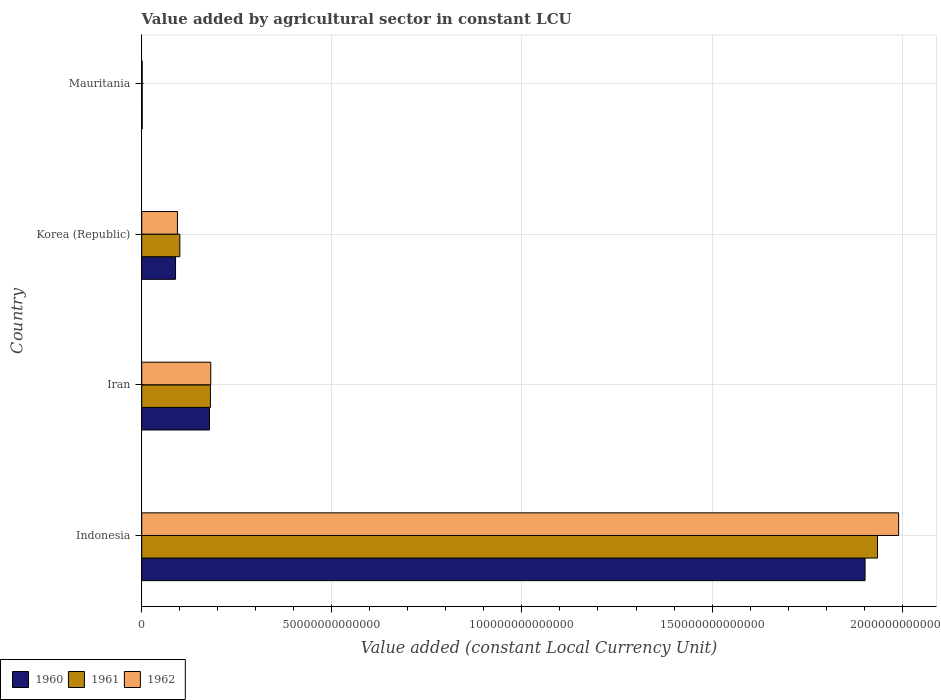Are the number of bars on each tick of the Y-axis equal?
Your response must be concise. Yes. What is the value added by agricultural sector in 1962 in Korea (Republic)?
Make the answer very short. 9.39e+12. Across all countries, what is the maximum value added by agricultural sector in 1960?
Ensure brevity in your answer.  1.90e+14. Across all countries, what is the minimum value added by agricultural sector in 1961?
Your response must be concise. 1.23e+11. In which country was the value added by agricultural sector in 1962 minimum?
Make the answer very short. Mauritania. What is the total value added by agricultural sector in 1961 in the graph?
Your response must be concise. 2.22e+14. What is the difference between the value added by agricultural sector in 1960 in Indonesia and that in Korea (Republic)?
Give a very brief answer. 1.81e+14. What is the difference between the value added by agricultural sector in 1962 in Iran and the value added by agricultural sector in 1960 in Korea (Republic)?
Provide a succinct answer. 9.26e+12. What is the average value added by agricultural sector in 1962 per country?
Ensure brevity in your answer.  5.67e+13. What is the difference between the value added by agricultural sector in 1960 and value added by agricultural sector in 1961 in Indonesia?
Offer a terse response. -3.27e+12. In how many countries, is the value added by agricultural sector in 1962 greater than 150000000000000 LCU?
Ensure brevity in your answer.  1. What is the ratio of the value added by agricultural sector in 1962 in Indonesia to that in Iran?
Ensure brevity in your answer.  10.96. What is the difference between the highest and the second highest value added by agricultural sector in 1960?
Offer a very short reply. 1.72e+14. What is the difference between the highest and the lowest value added by agricultural sector in 1960?
Your answer should be compact. 1.90e+14. In how many countries, is the value added by agricultural sector in 1961 greater than the average value added by agricultural sector in 1961 taken over all countries?
Offer a very short reply. 1. What does the 2nd bar from the top in Iran represents?
Give a very brief answer. 1961. What does the 2nd bar from the bottom in Indonesia represents?
Give a very brief answer. 1961. Is it the case that in every country, the sum of the value added by agricultural sector in 1960 and value added by agricultural sector in 1962 is greater than the value added by agricultural sector in 1961?
Make the answer very short. Yes. How many bars are there?
Give a very brief answer. 12. Are all the bars in the graph horizontal?
Your answer should be compact. Yes. What is the difference between two consecutive major ticks on the X-axis?
Offer a very short reply. 5.00e+13. Does the graph contain any zero values?
Keep it short and to the point. No. Does the graph contain grids?
Ensure brevity in your answer.  Yes. Where does the legend appear in the graph?
Provide a succinct answer. Bottom left. How are the legend labels stacked?
Your answer should be compact. Horizontal. What is the title of the graph?
Offer a terse response. Value added by agricultural sector in constant LCU. What is the label or title of the X-axis?
Offer a very short reply. Value added (constant Local Currency Unit). What is the Value added (constant Local Currency Unit) in 1960 in Indonesia?
Your response must be concise. 1.90e+14. What is the Value added (constant Local Currency Unit) of 1961 in Indonesia?
Your response must be concise. 1.94e+14. What is the Value added (constant Local Currency Unit) in 1962 in Indonesia?
Keep it short and to the point. 1.99e+14. What is the Value added (constant Local Currency Unit) of 1960 in Iran?
Make the answer very short. 1.78e+13. What is the Value added (constant Local Currency Unit) in 1961 in Iran?
Offer a terse response. 1.81e+13. What is the Value added (constant Local Currency Unit) in 1962 in Iran?
Keep it short and to the point. 1.82e+13. What is the Value added (constant Local Currency Unit) in 1960 in Korea (Republic)?
Give a very brief answer. 8.90e+12. What is the Value added (constant Local Currency Unit) in 1961 in Korea (Republic)?
Offer a very short reply. 1.00e+13. What is the Value added (constant Local Currency Unit) in 1962 in Korea (Republic)?
Keep it short and to the point. 9.39e+12. What is the Value added (constant Local Currency Unit) of 1960 in Mauritania?
Your answer should be compact. 1.27e+11. What is the Value added (constant Local Currency Unit) in 1961 in Mauritania?
Offer a terse response. 1.23e+11. What is the Value added (constant Local Currency Unit) of 1962 in Mauritania?
Your response must be concise. 1.20e+11. Across all countries, what is the maximum Value added (constant Local Currency Unit) in 1960?
Make the answer very short. 1.90e+14. Across all countries, what is the maximum Value added (constant Local Currency Unit) in 1961?
Your answer should be very brief. 1.94e+14. Across all countries, what is the maximum Value added (constant Local Currency Unit) of 1962?
Make the answer very short. 1.99e+14. Across all countries, what is the minimum Value added (constant Local Currency Unit) in 1960?
Keep it short and to the point. 1.27e+11. Across all countries, what is the minimum Value added (constant Local Currency Unit) of 1961?
Offer a terse response. 1.23e+11. Across all countries, what is the minimum Value added (constant Local Currency Unit) of 1962?
Your answer should be very brief. 1.20e+11. What is the total Value added (constant Local Currency Unit) in 1960 in the graph?
Provide a short and direct response. 2.17e+14. What is the total Value added (constant Local Currency Unit) of 1961 in the graph?
Your answer should be compact. 2.22e+14. What is the total Value added (constant Local Currency Unit) of 1962 in the graph?
Offer a terse response. 2.27e+14. What is the difference between the Value added (constant Local Currency Unit) in 1960 in Indonesia and that in Iran?
Provide a succinct answer. 1.72e+14. What is the difference between the Value added (constant Local Currency Unit) in 1961 in Indonesia and that in Iran?
Keep it short and to the point. 1.75e+14. What is the difference between the Value added (constant Local Currency Unit) of 1962 in Indonesia and that in Iran?
Your response must be concise. 1.81e+14. What is the difference between the Value added (constant Local Currency Unit) of 1960 in Indonesia and that in Korea (Republic)?
Provide a short and direct response. 1.81e+14. What is the difference between the Value added (constant Local Currency Unit) in 1961 in Indonesia and that in Korea (Republic)?
Your answer should be very brief. 1.83e+14. What is the difference between the Value added (constant Local Currency Unit) of 1962 in Indonesia and that in Korea (Republic)?
Provide a succinct answer. 1.90e+14. What is the difference between the Value added (constant Local Currency Unit) of 1960 in Indonesia and that in Mauritania?
Your answer should be very brief. 1.90e+14. What is the difference between the Value added (constant Local Currency Unit) of 1961 in Indonesia and that in Mauritania?
Keep it short and to the point. 1.93e+14. What is the difference between the Value added (constant Local Currency Unit) in 1962 in Indonesia and that in Mauritania?
Give a very brief answer. 1.99e+14. What is the difference between the Value added (constant Local Currency Unit) of 1960 in Iran and that in Korea (Republic)?
Your answer should be compact. 8.93e+12. What is the difference between the Value added (constant Local Currency Unit) in 1961 in Iran and that in Korea (Republic)?
Your answer should be compact. 8.05e+12. What is the difference between the Value added (constant Local Currency Unit) of 1962 in Iran and that in Korea (Republic)?
Keep it short and to the point. 8.77e+12. What is the difference between the Value added (constant Local Currency Unit) in 1960 in Iran and that in Mauritania?
Your answer should be compact. 1.77e+13. What is the difference between the Value added (constant Local Currency Unit) of 1961 in Iran and that in Mauritania?
Provide a short and direct response. 1.79e+13. What is the difference between the Value added (constant Local Currency Unit) in 1962 in Iran and that in Mauritania?
Your answer should be very brief. 1.80e+13. What is the difference between the Value added (constant Local Currency Unit) of 1960 in Korea (Republic) and that in Mauritania?
Offer a very short reply. 8.77e+12. What is the difference between the Value added (constant Local Currency Unit) in 1961 in Korea (Republic) and that in Mauritania?
Give a very brief answer. 9.90e+12. What is the difference between the Value added (constant Local Currency Unit) of 1962 in Korea (Republic) and that in Mauritania?
Provide a succinct answer. 9.27e+12. What is the difference between the Value added (constant Local Currency Unit) of 1960 in Indonesia and the Value added (constant Local Currency Unit) of 1961 in Iran?
Ensure brevity in your answer.  1.72e+14. What is the difference between the Value added (constant Local Currency Unit) in 1960 in Indonesia and the Value added (constant Local Currency Unit) in 1962 in Iran?
Ensure brevity in your answer.  1.72e+14. What is the difference between the Value added (constant Local Currency Unit) in 1961 in Indonesia and the Value added (constant Local Currency Unit) in 1962 in Iran?
Your answer should be very brief. 1.75e+14. What is the difference between the Value added (constant Local Currency Unit) of 1960 in Indonesia and the Value added (constant Local Currency Unit) of 1961 in Korea (Republic)?
Your answer should be very brief. 1.80e+14. What is the difference between the Value added (constant Local Currency Unit) in 1960 in Indonesia and the Value added (constant Local Currency Unit) in 1962 in Korea (Republic)?
Your response must be concise. 1.81e+14. What is the difference between the Value added (constant Local Currency Unit) in 1961 in Indonesia and the Value added (constant Local Currency Unit) in 1962 in Korea (Republic)?
Provide a short and direct response. 1.84e+14. What is the difference between the Value added (constant Local Currency Unit) of 1960 in Indonesia and the Value added (constant Local Currency Unit) of 1961 in Mauritania?
Give a very brief answer. 1.90e+14. What is the difference between the Value added (constant Local Currency Unit) of 1960 in Indonesia and the Value added (constant Local Currency Unit) of 1962 in Mauritania?
Provide a short and direct response. 1.90e+14. What is the difference between the Value added (constant Local Currency Unit) in 1961 in Indonesia and the Value added (constant Local Currency Unit) in 1962 in Mauritania?
Keep it short and to the point. 1.93e+14. What is the difference between the Value added (constant Local Currency Unit) of 1960 in Iran and the Value added (constant Local Currency Unit) of 1961 in Korea (Republic)?
Your answer should be very brief. 7.81e+12. What is the difference between the Value added (constant Local Currency Unit) in 1960 in Iran and the Value added (constant Local Currency Unit) in 1962 in Korea (Republic)?
Give a very brief answer. 8.44e+12. What is the difference between the Value added (constant Local Currency Unit) in 1961 in Iran and the Value added (constant Local Currency Unit) in 1962 in Korea (Republic)?
Make the answer very short. 8.68e+12. What is the difference between the Value added (constant Local Currency Unit) of 1960 in Iran and the Value added (constant Local Currency Unit) of 1961 in Mauritania?
Keep it short and to the point. 1.77e+13. What is the difference between the Value added (constant Local Currency Unit) in 1960 in Iran and the Value added (constant Local Currency Unit) in 1962 in Mauritania?
Keep it short and to the point. 1.77e+13. What is the difference between the Value added (constant Local Currency Unit) of 1961 in Iran and the Value added (constant Local Currency Unit) of 1962 in Mauritania?
Your response must be concise. 1.80e+13. What is the difference between the Value added (constant Local Currency Unit) in 1960 in Korea (Republic) and the Value added (constant Local Currency Unit) in 1961 in Mauritania?
Provide a short and direct response. 8.77e+12. What is the difference between the Value added (constant Local Currency Unit) in 1960 in Korea (Republic) and the Value added (constant Local Currency Unit) in 1962 in Mauritania?
Your answer should be very brief. 8.78e+12. What is the difference between the Value added (constant Local Currency Unit) in 1961 in Korea (Republic) and the Value added (constant Local Currency Unit) in 1962 in Mauritania?
Your answer should be compact. 9.90e+12. What is the average Value added (constant Local Currency Unit) of 1960 per country?
Ensure brevity in your answer.  5.43e+13. What is the average Value added (constant Local Currency Unit) of 1961 per country?
Offer a terse response. 5.54e+13. What is the average Value added (constant Local Currency Unit) in 1962 per country?
Ensure brevity in your answer.  5.67e+13. What is the difference between the Value added (constant Local Currency Unit) in 1960 and Value added (constant Local Currency Unit) in 1961 in Indonesia?
Offer a terse response. -3.27e+12. What is the difference between the Value added (constant Local Currency Unit) of 1960 and Value added (constant Local Currency Unit) of 1962 in Indonesia?
Make the answer very short. -8.83e+12. What is the difference between the Value added (constant Local Currency Unit) in 1961 and Value added (constant Local Currency Unit) in 1962 in Indonesia?
Provide a succinct answer. -5.56e+12. What is the difference between the Value added (constant Local Currency Unit) of 1960 and Value added (constant Local Currency Unit) of 1961 in Iran?
Provide a succinct answer. -2.42e+11. What is the difference between the Value added (constant Local Currency Unit) of 1960 and Value added (constant Local Currency Unit) of 1962 in Iran?
Provide a short and direct response. -3.32e+11. What is the difference between the Value added (constant Local Currency Unit) of 1961 and Value added (constant Local Currency Unit) of 1962 in Iran?
Give a very brief answer. -8.95e+1. What is the difference between the Value added (constant Local Currency Unit) of 1960 and Value added (constant Local Currency Unit) of 1961 in Korea (Republic)?
Keep it short and to the point. -1.12e+12. What is the difference between the Value added (constant Local Currency Unit) in 1960 and Value added (constant Local Currency Unit) in 1962 in Korea (Republic)?
Keep it short and to the point. -4.93e+11. What is the difference between the Value added (constant Local Currency Unit) of 1961 and Value added (constant Local Currency Unit) of 1962 in Korea (Republic)?
Offer a terse response. 6.31e+11. What is the difference between the Value added (constant Local Currency Unit) in 1960 and Value added (constant Local Currency Unit) in 1961 in Mauritania?
Provide a short and direct response. 4.01e+09. What is the difference between the Value added (constant Local Currency Unit) in 1960 and Value added (constant Local Currency Unit) in 1962 in Mauritania?
Your response must be concise. 7.67e+09. What is the difference between the Value added (constant Local Currency Unit) in 1961 and Value added (constant Local Currency Unit) in 1962 in Mauritania?
Provide a succinct answer. 3.65e+09. What is the ratio of the Value added (constant Local Currency Unit) in 1960 in Indonesia to that in Iran?
Provide a succinct answer. 10.67. What is the ratio of the Value added (constant Local Currency Unit) in 1961 in Indonesia to that in Iran?
Ensure brevity in your answer.  10.71. What is the ratio of the Value added (constant Local Currency Unit) of 1962 in Indonesia to that in Iran?
Your answer should be very brief. 10.96. What is the ratio of the Value added (constant Local Currency Unit) in 1960 in Indonesia to that in Korea (Republic)?
Keep it short and to the point. 21.38. What is the ratio of the Value added (constant Local Currency Unit) in 1961 in Indonesia to that in Korea (Republic)?
Offer a very short reply. 19.31. What is the ratio of the Value added (constant Local Currency Unit) of 1962 in Indonesia to that in Korea (Republic)?
Your answer should be compact. 21.2. What is the ratio of the Value added (constant Local Currency Unit) of 1960 in Indonesia to that in Mauritania?
Your answer should be compact. 1494.5. What is the ratio of the Value added (constant Local Currency Unit) of 1961 in Indonesia to that in Mauritania?
Give a very brief answer. 1569.7. What is the ratio of the Value added (constant Local Currency Unit) in 1962 in Indonesia to that in Mauritania?
Give a very brief answer. 1664.14. What is the ratio of the Value added (constant Local Currency Unit) in 1960 in Iran to that in Korea (Republic)?
Keep it short and to the point. 2. What is the ratio of the Value added (constant Local Currency Unit) of 1961 in Iran to that in Korea (Republic)?
Your answer should be compact. 1.8. What is the ratio of the Value added (constant Local Currency Unit) of 1962 in Iran to that in Korea (Republic)?
Your answer should be compact. 1.93. What is the ratio of the Value added (constant Local Currency Unit) of 1960 in Iran to that in Mauritania?
Keep it short and to the point. 140.05. What is the ratio of the Value added (constant Local Currency Unit) in 1961 in Iran to that in Mauritania?
Give a very brief answer. 146.57. What is the ratio of the Value added (constant Local Currency Unit) of 1962 in Iran to that in Mauritania?
Keep it short and to the point. 151.8. What is the ratio of the Value added (constant Local Currency Unit) in 1960 in Korea (Republic) to that in Mauritania?
Ensure brevity in your answer.  69.9. What is the ratio of the Value added (constant Local Currency Unit) in 1961 in Korea (Republic) to that in Mauritania?
Offer a very short reply. 81.29. What is the ratio of the Value added (constant Local Currency Unit) of 1962 in Korea (Republic) to that in Mauritania?
Your answer should be compact. 78.51. What is the difference between the highest and the second highest Value added (constant Local Currency Unit) in 1960?
Give a very brief answer. 1.72e+14. What is the difference between the highest and the second highest Value added (constant Local Currency Unit) of 1961?
Ensure brevity in your answer.  1.75e+14. What is the difference between the highest and the second highest Value added (constant Local Currency Unit) of 1962?
Provide a short and direct response. 1.81e+14. What is the difference between the highest and the lowest Value added (constant Local Currency Unit) of 1960?
Your answer should be very brief. 1.90e+14. What is the difference between the highest and the lowest Value added (constant Local Currency Unit) in 1961?
Make the answer very short. 1.93e+14. What is the difference between the highest and the lowest Value added (constant Local Currency Unit) of 1962?
Ensure brevity in your answer.  1.99e+14. 